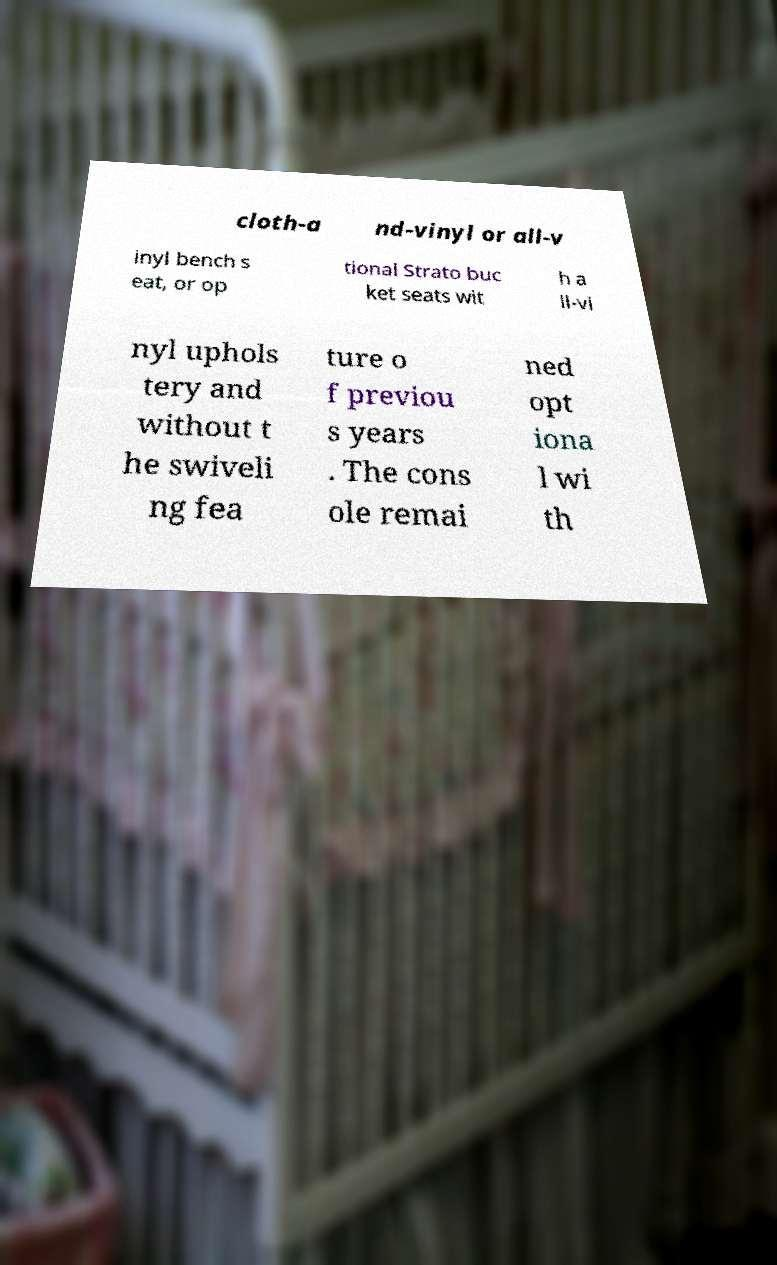Can you accurately transcribe the text from the provided image for me? cloth-a nd-vinyl or all-v inyl bench s eat, or op tional Strato buc ket seats wit h a ll-vi nyl uphols tery and without t he swiveli ng fea ture o f previou s years . The cons ole remai ned opt iona l wi th 